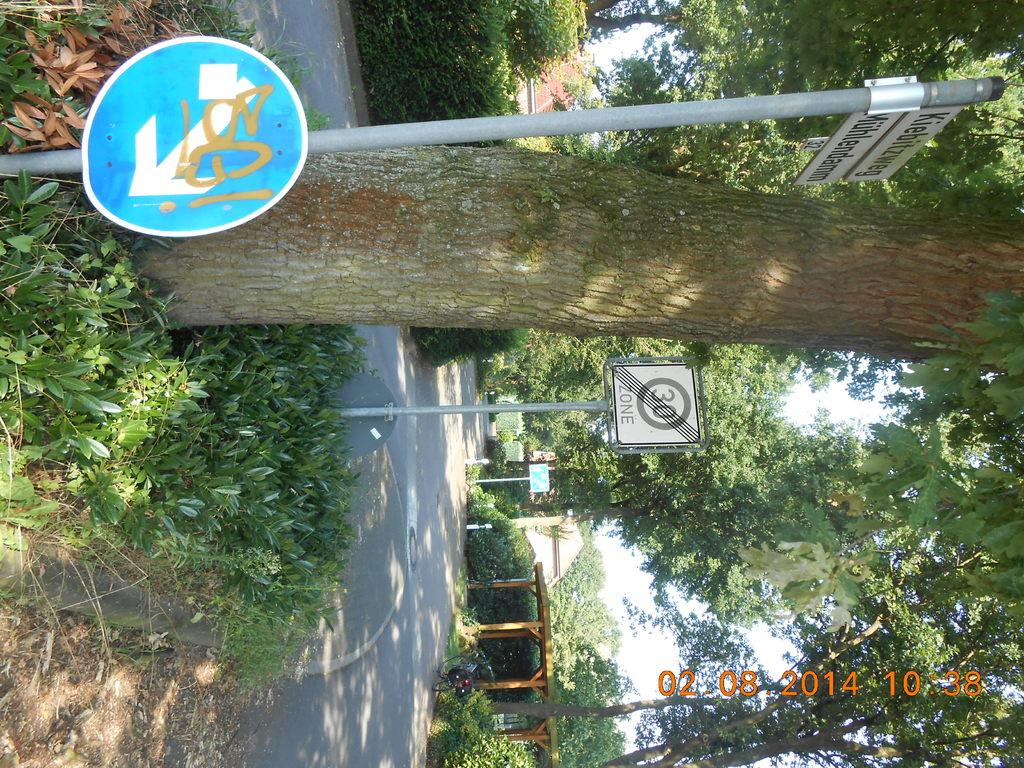Provide a one-sentence caption for the provided image. A traffic sign on a tree line road shows it as a 30 zone. 